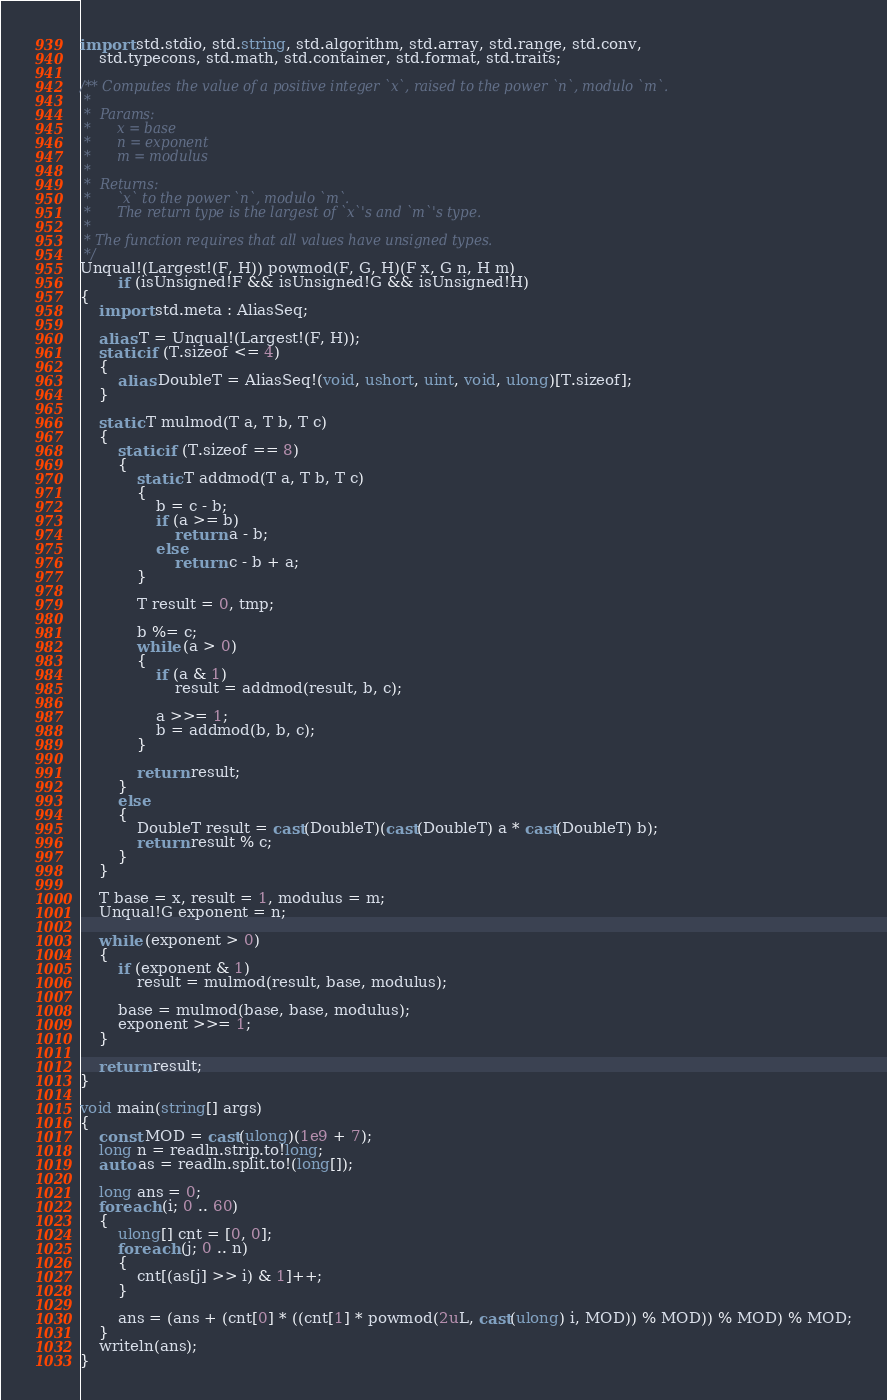Convert code to text. <code><loc_0><loc_0><loc_500><loc_500><_D_>import std.stdio, std.string, std.algorithm, std.array, std.range, std.conv,
    std.typecons, std.math, std.container, std.format, std.traits;

/** Computes the value of a positive integer `x`, raised to the power `n`, modulo `m`.
 *
 *  Params:
 *      x = base
 *      n = exponent
 *      m = modulus
 *
 *  Returns:
 *      `x` to the power `n`, modulo `m`.
 *      The return type is the largest of `x`'s and `m`'s type.
 *
 * The function requires that all values have unsigned types.
 */
Unqual!(Largest!(F, H)) powmod(F, G, H)(F x, G n, H m)
        if (isUnsigned!F && isUnsigned!G && isUnsigned!H)
{
    import std.meta : AliasSeq;

    alias T = Unqual!(Largest!(F, H));
    static if (T.sizeof <= 4)
    {
        alias DoubleT = AliasSeq!(void, ushort, uint, void, ulong)[T.sizeof];
    }

    static T mulmod(T a, T b, T c)
    {
        static if (T.sizeof == 8)
        {
            static T addmod(T a, T b, T c)
            {
                b = c - b;
                if (a >= b)
                    return a - b;
                else
                    return c - b + a;
            }

            T result = 0, tmp;

            b %= c;
            while (a > 0)
            {
                if (a & 1)
                    result = addmod(result, b, c);

                a >>= 1;
                b = addmod(b, b, c);
            }

            return result;
        }
        else
        {
            DoubleT result = cast(DoubleT)(cast(DoubleT) a * cast(DoubleT) b);
            return result % c;
        }
    }

    T base = x, result = 1, modulus = m;
    Unqual!G exponent = n;

    while (exponent > 0)
    {
        if (exponent & 1)
            result = mulmod(result, base, modulus);

        base = mulmod(base, base, modulus);
        exponent >>= 1;
    }

    return result;
}

void main(string[] args)
{
    const MOD = cast(ulong)(1e9 + 7);
    long n = readln.strip.to!long;
    auto as = readln.split.to!(long[]);

    long ans = 0;
    foreach (i; 0 .. 60)
    {
        ulong[] cnt = [0, 0];
        foreach (j; 0 .. n)
        {
            cnt[(as[j] >> i) & 1]++;
        }

        ans = (ans + (cnt[0] * ((cnt[1] * powmod(2uL, cast(ulong) i, MOD)) % MOD)) % MOD) % MOD;
    }
    writeln(ans);
}
</code> 